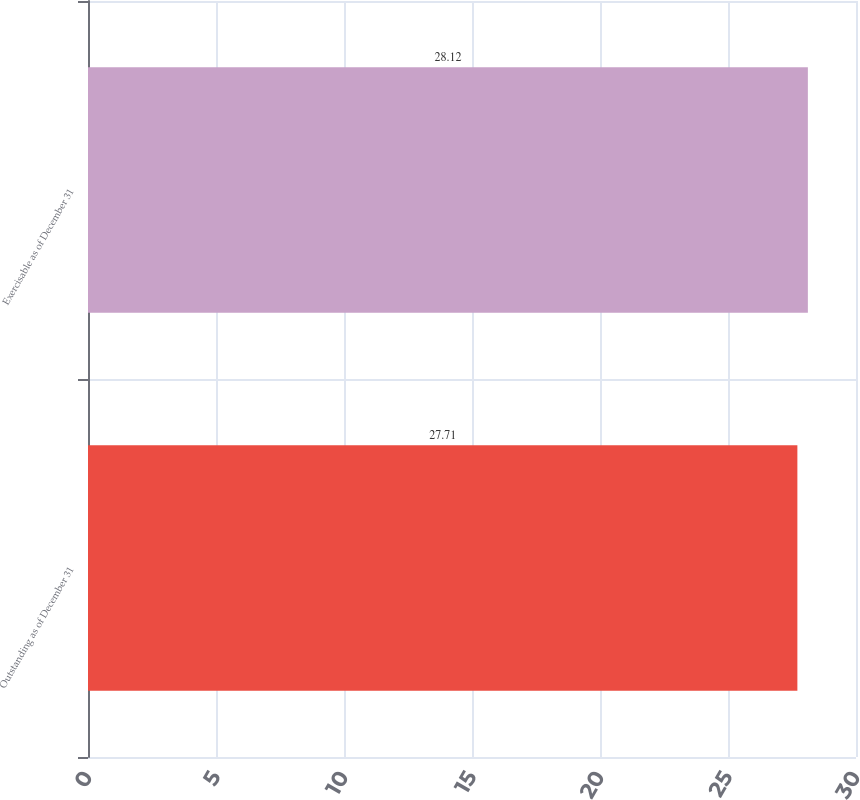Convert chart. <chart><loc_0><loc_0><loc_500><loc_500><bar_chart><fcel>Outstanding as of December 31<fcel>Exercisable as of December 31<nl><fcel>27.71<fcel>28.12<nl></chart> 